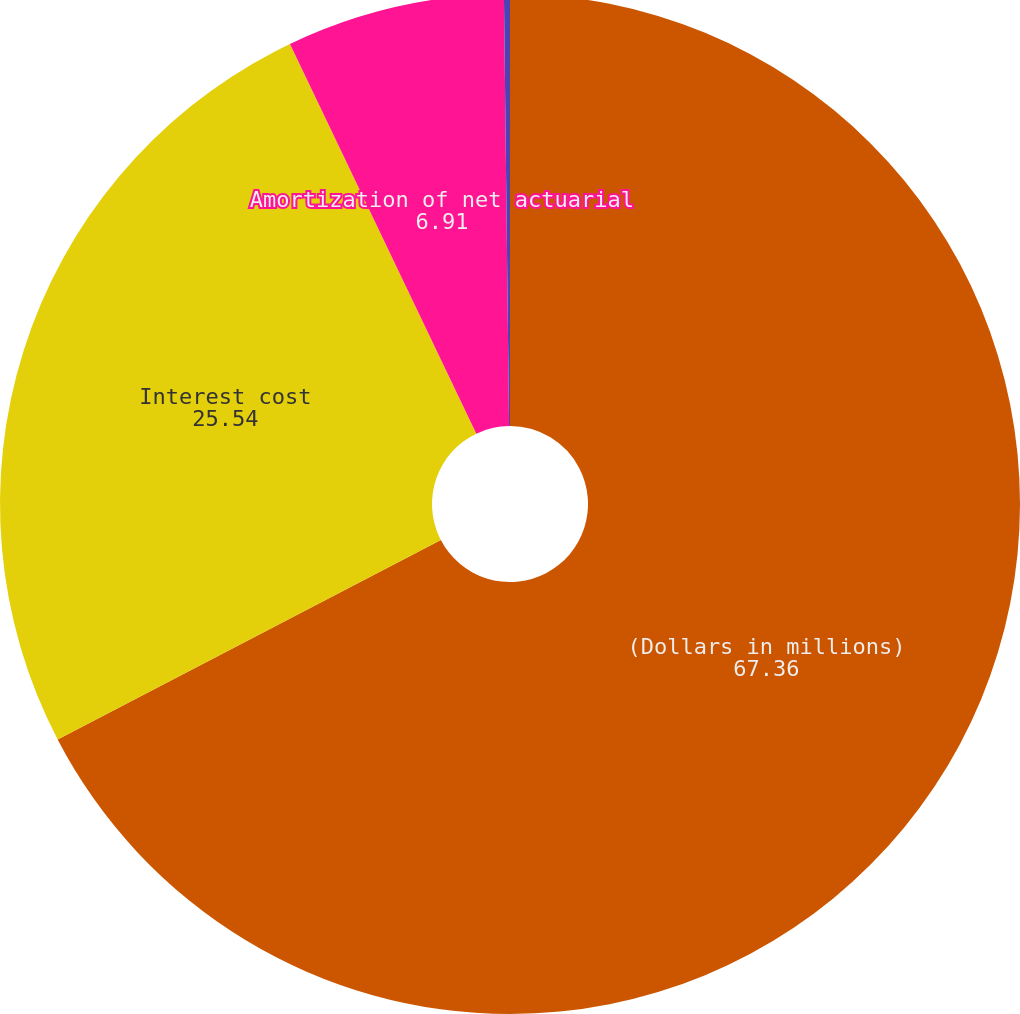Convert chart. <chart><loc_0><loc_0><loc_500><loc_500><pie_chart><fcel>(Dollars in millions)<fcel>Interest cost<fcel>Amortization of net actuarial<fcel>Discount rate<nl><fcel>67.36%<fcel>25.54%<fcel>6.91%<fcel>0.19%<nl></chart> 